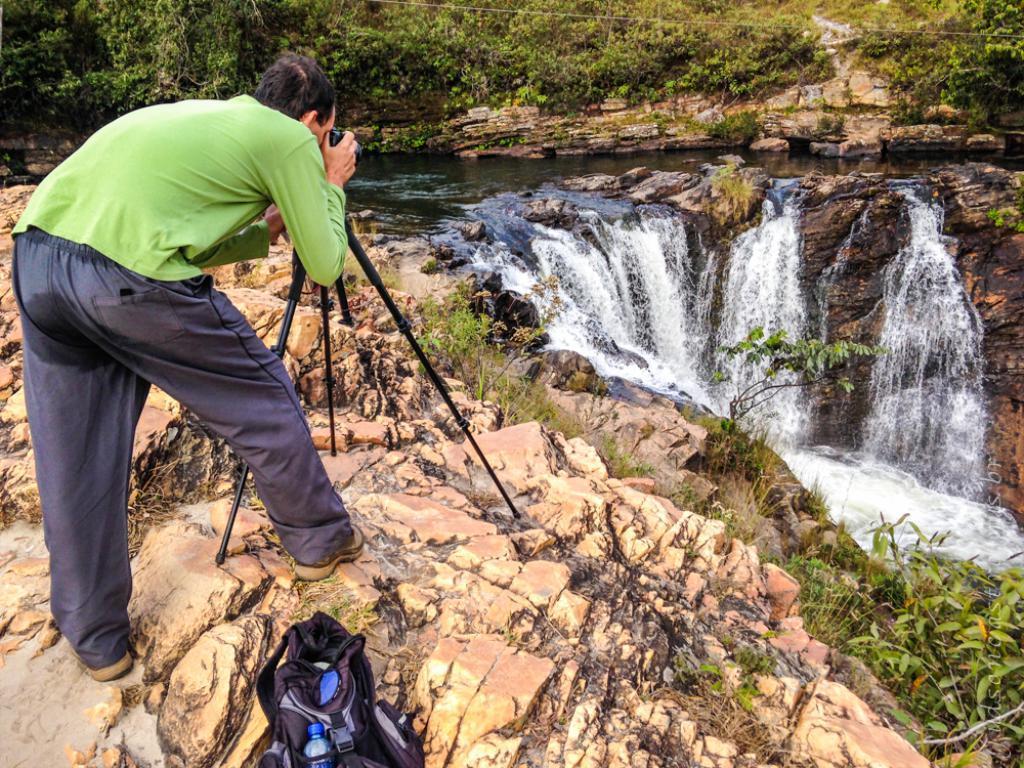Could you give a brief overview of what you see in this image? In this picture we can see a man standing on rocks and holding a camera with his hands, bag, tripod stand, water and in the background we can see trees. 